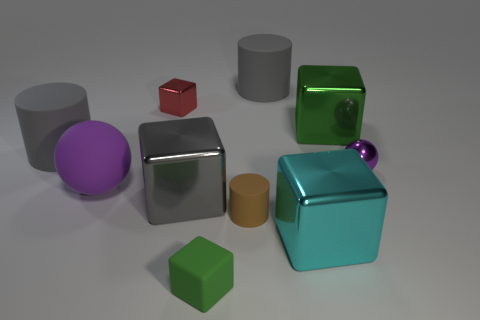There is a cyan metal thing; does it have the same size as the purple sphere right of the tiny brown thing?
Offer a very short reply. No. How many spheres have the same size as the red cube?
Offer a terse response. 1. How many small things are either purple spheres or cyan cubes?
Your response must be concise. 1. Are any brown matte blocks visible?
Offer a terse response. No. Is the number of cylinders on the left side of the brown rubber thing greater than the number of purple rubber balls in front of the big cyan metal object?
Offer a very short reply. Yes. What is the color of the metal thing that is right of the green block that is on the right side of the cyan metallic object?
Keep it short and to the point. Purple. Is there a matte object of the same color as the matte cube?
Your answer should be very brief. No. There is a purple sphere to the left of the green cube that is to the left of the big metal block that is right of the large cyan shiny thing; how big is it?
Keep it short and to the point. Large. What shape is the big green shiny thing?
Keep it short and to the point. Cube. There is a thing that is the same color as the metal ball; what is its size?
Make the answer very short. Large. 